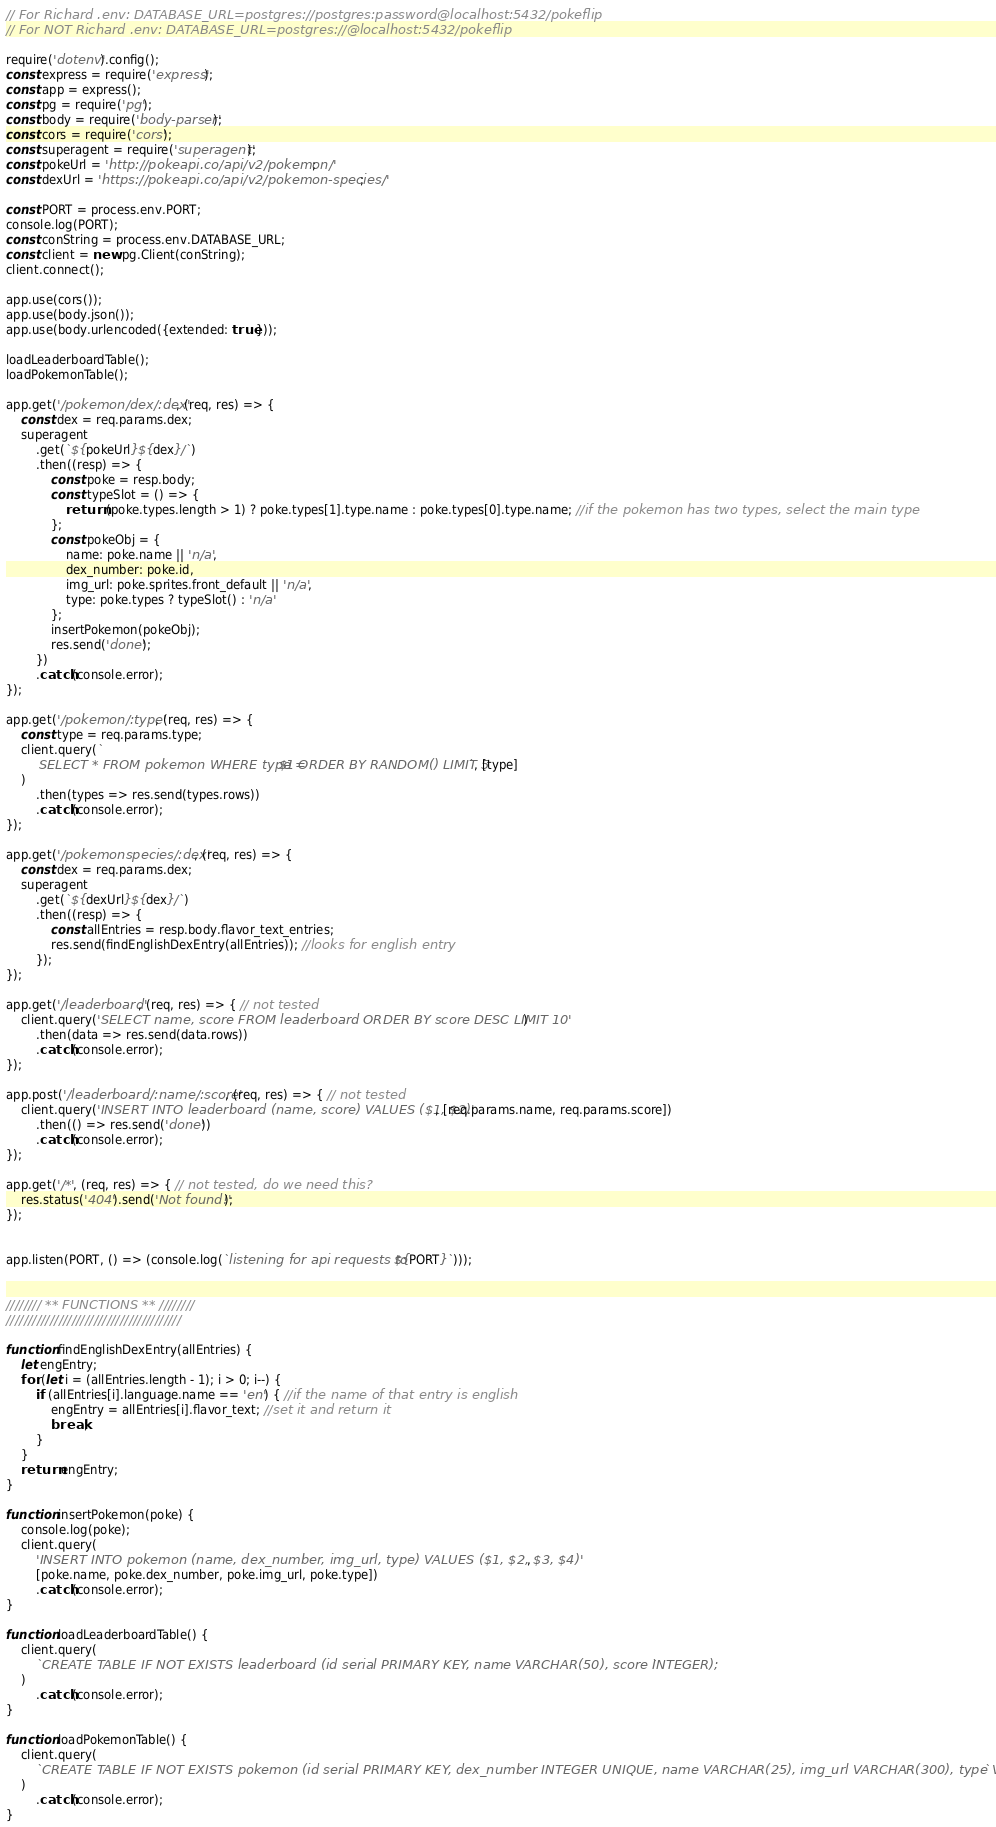<code> <loc_0><loc_0><loc_500><loc_500><_JavaScript_>// For Richard .env: DATABASE_URL=postgres://postgres:password@localhost:5432/pokeflip
// For NOT Richard .env: DATABASE_URL=postgres://@localhost:5432/pokeflip

require('dotenv').config();
const express = require('express');
const app = express();
const pg = require('pg');
const body = require('body-parser');
const cors = require('cors');
const superagent = require('superagent');
const pokeUrl = 'http://pokeapi.co/api/v2/pokemon/';
const dexUrl = 'https://pokeapi.co/api/v2/pokemon-species/';

const PORT = process.env.PORT;
console.log(PORT);
const conString = process.env.DATABASE_URL;
const client = new pg.Client(conString);
client.connect();

app.use(cors());
app.use(body.json());
app.use(body.urlencoded({extended: true}));

loadLeaderboardTable();
loadPokemonTable();

app.get('/pokemon/dex/:dex', (req, res) => {
    const dex = req.params.dex;
    superagent
        .get(`${pokeUrl}${dex}/`)
        .then((resp) => {
            const poke = resp.body;
            const typeSlot = () => {
                return (poke.types.length > 1) ? poke.types[1].type.name : poke.types[0].type.name; //if the pokemon has two types, select the main type
            };
            const pokeObj = {
                name: poke.name || 'n/a',
                dex_number: poke.id,
                img_url: poke.sprites.front_default || 'n/a',
                type: poke.types ? typeSlot() : 'n/a'
            };
            insertPokemon(pokeObj);
            res.send('done');
        })
        .catch(console.error);
});

app.get('/pokemon/:type', (req, res) => {
    const type = req.params.type;
    client.query(`
        SELECT * FROM pokemon WHERE type = $1 ORDER BY RANDOM() LIMIT 5`, [type]
    )
        .then(types => res.send(types.rows))
        .catch(console.error);
});

app.get('/pokemonspecies/:dex', (req, res) => {
    const dex = req.params.dex;
    superagent
        .get(`${dexUrl}${dex}/`)
        .then((resp) => {
            const allEntries = resp.body.flavor_text_entries;
            res.send(findEnglishDexEntry(allEntries)); //looks for english entry
        });
});

app.get('/leaderboard', (req, res) => { // not tested
    client.query('SELECT name, score FROM leaderboard ORDER BY score DESC LIMIT 10')
        .then(data => res.send(data.rows))
        .catch(console.error);
});

app.post('/leaderboard/:name/:score', (req, res) => { // not tested
    client.query('INSERT INTO leaderboard (name, score) VALUES ($1, $2)', [req.params.name, req.params.score])
        .then(() => res.send('done'))
        .catch(console.error);
});

app.get('/*', (req, res) => { // not tested, do we need this?
    res.status('404').send('Not found!');
});


app.listen(PORT, () => (console.log(`listening for api requests to ${PORT}`)));


//////// ** FUNCTIONS ** ////////
////////////////////////////////////////

function findEnglishDexEntry(allEntries) {
    let engEntry;
    for (let i = (allEntries.length - 1); i > 0; i--) {
        if (allEntries[i].language.name == 'en') { //if the name of that entry is english
            engEntry = allEntries[i].flavor_text; //set it and return it
            break;
        }
    }
    return engEntry;
}

function insertPokemon(poke) {
    console.log(poke);
    client.query(
        'INSERT INTO pokemon (name, dex_number, img_url, type) VALUES ($1, $2, $3, $4)',
        [poke.name, poke.dex_number, poke.img_url, poke.type])
        .catch(console.error);
}

function loadLeaderboardTable() {
    client.query(
        `CREATE TABLE IF NOT EXISTS leaderboard (id serial PRIMARY KEY, name VARCHAR(50), score INTEGER);`
    )
        .catch(console.error);
}

function loadPokemonTable() {
    client.query(
        `CREATE TABLE IF NOT EXISTS pokemon (id serial PRIMARY KEY, dex_number INTEGER UNIQUE, name VARCHAR(25), img_url VARCHAR(300), type VARCHAR(25));`
    )
        .catch(console.error);
}</code> 